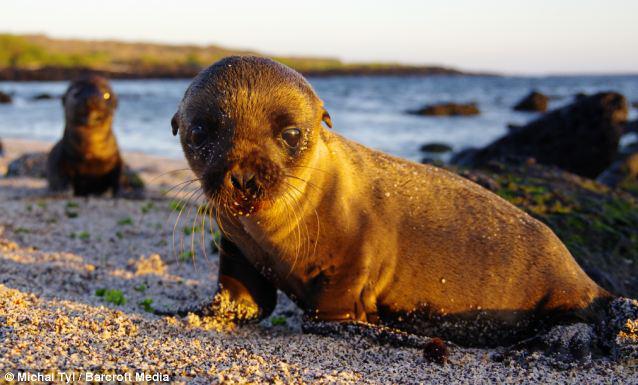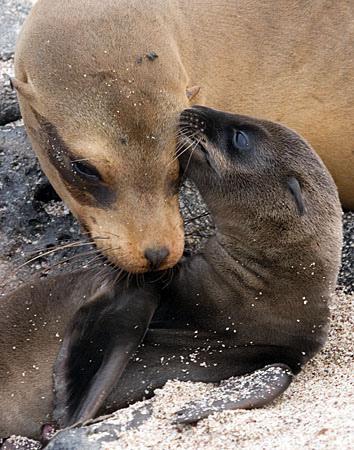The first image is the image on the left, the second image is the image on the right. For the images displayed, is the sentence "There are exactly two sea lions in total." factually correct? Answer yes or no. No. The first image is the image on the left, the second image is the image on the right. For the images displayed, is the sentence "One image features a baby sea lion next to an adult sea lion" factually correct? Answer yes or no. Yes. 